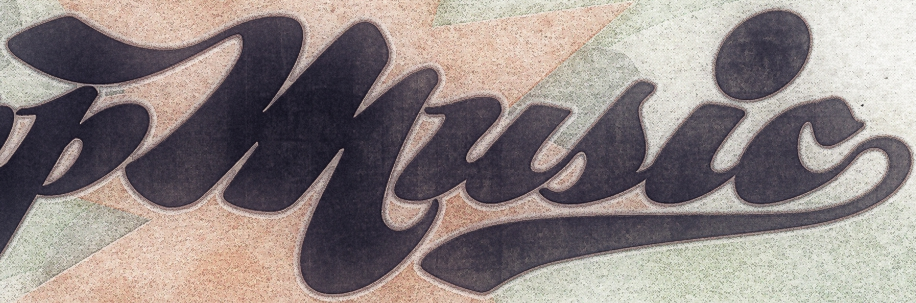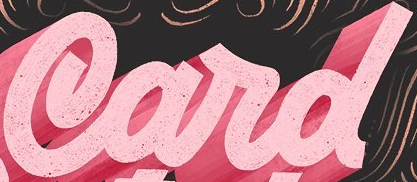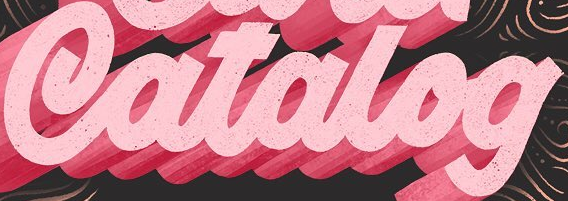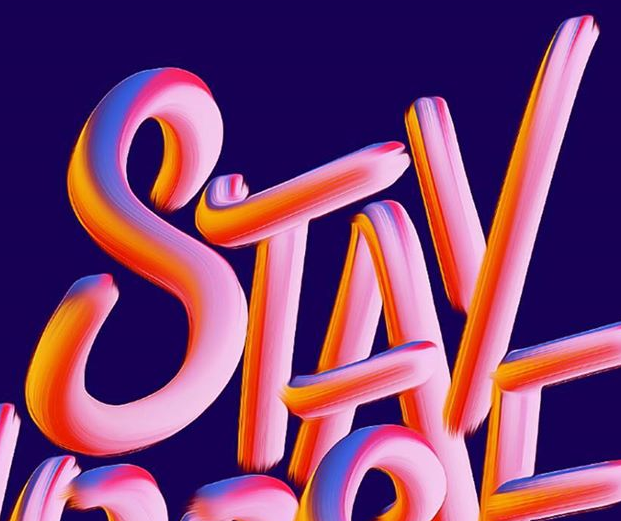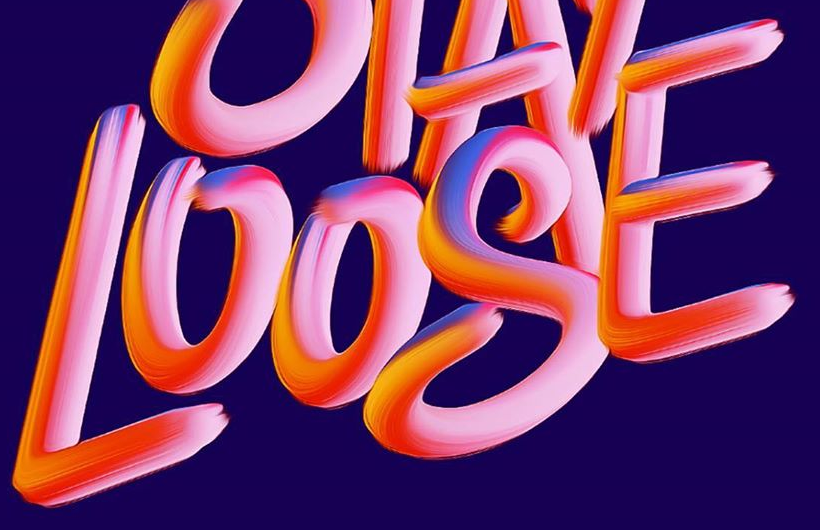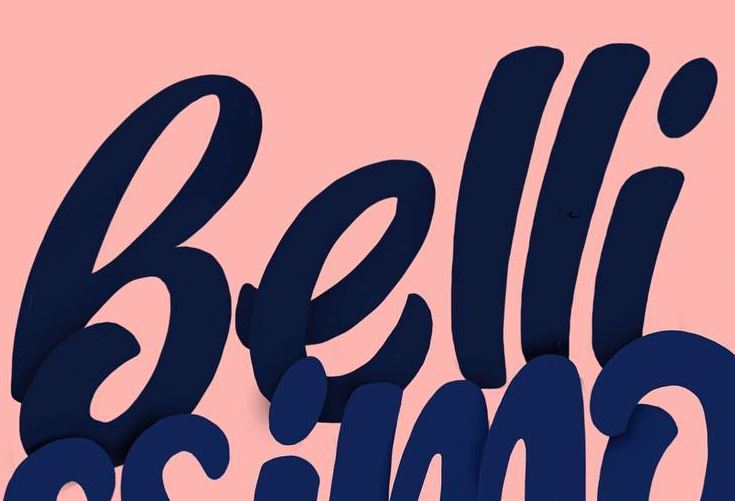Read the text content from these images in order, separated by a semicolon. music; Card; Catalog; STAY; LOOSE; Belli 